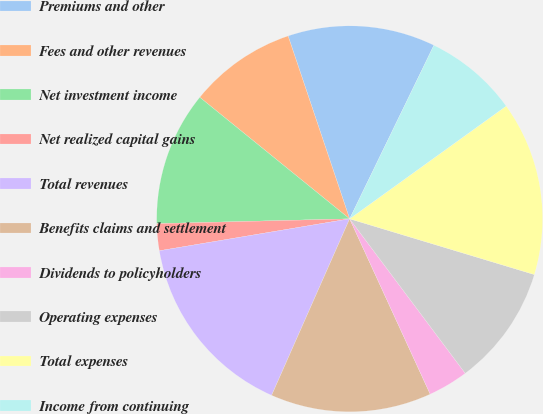Convert chart. <chart><loc_0><loc_0><loc_500><loc_500><pie_chart><fcel>Premiums and other<fcel>Fees and other revenues<fcel>Net investment income<fcel>Net realized capital gains<fcel>Total revenues<fcel>Benefits claims and settlement<fcel>Dividends to policyholders<fcel>Operating expenses<fcel>Total expenses<fcel>Income from continuing<nl><fcel>12.36%<fcel>8.99%<fcel>11.24%<fcel>2.25%<fcel>15.73%<fcel>13.48%<fcel>3.37%<fcel>10.11%<fcel>14.6%<fcel>7.87%<nl></chart> 